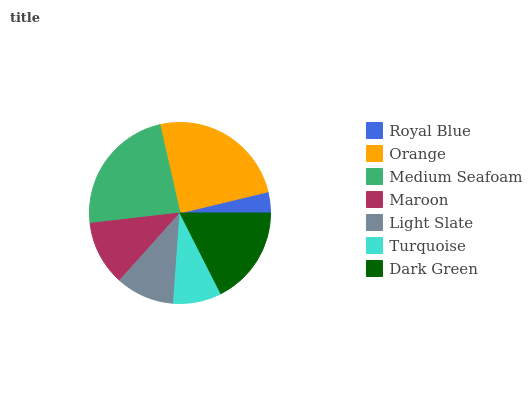Is Royal Blue the minimum?
Answer yes or no. Yes. Is Orange the maximum?
Answer yes or no. Yes. Is Medium Seafoam the minimum?
Answer yes or no. No. Is Medium Seafoam the maximum?
Answer yes or no. No. Is Orange greater than Medium Seafoam?
Answer yes or no. Yes. Is Medium Seafoam less than Orange?
Answer yes or no. Yes. Is Medium Seafoam greater than Orange?
Answer yes or no. No. Is Orange less than Medium Seafoam?
Answer yes or no. No. Is Maroon the high median?
Answer yes or no. Yes. Is Maroon the low median?
Answer yes or no. Yes. Is Medium Seafoam the high median?
Answer yes or no. No. Is Royal Blue the low median?
Answer yes or no. No. 